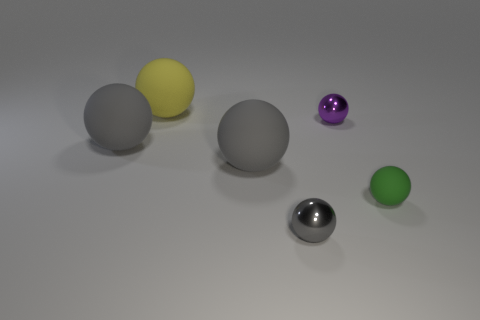Subtract all gray balls. How many were subtracted if there are1gray balls left? 2 Subtract all gray metal balls. How many balls are left? 5 Add 2 yellow matte objects. How many objects exist? 8 Add 3 big gray spheres. How many big gray spheres are left? 5 Add 4 small rubber spheres. How many small rubber spheres exist? 5 Subtract all gray balls. How many balls are left? 3 Subtract 0 brown cubes. How many objects are left? 6 Subtract 2 balls. How many balls are left? 4 Subtract all purple balls. Subtract all green blocks. How many balls are left? 5 Subtract all brown cylinders. How many purple balls are left? 1 